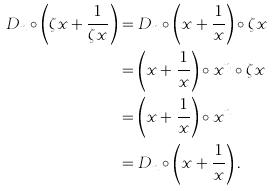Convert formula to latex. <formula><loc_0><loc_0><loc_500><loc_500>D _ { n } \circ \left ( \zeta x + \frac { 1 } { \zeta x } \right ) & = D _ { n } \circ \left ( x + \frac { 1 } { x } \right ) \circ \zeta x \\ & = \left ( x + \frac { 1 } { x } \right ) \circ x ^ { n } \circ \zeta x \\ & = \left ( x + \frac { 1 } { x } \right ) \circ x ^ { n } \\ & = D _ { n } \circ \left ( x + \frac { 1 } { x } \right ) .</formula> 